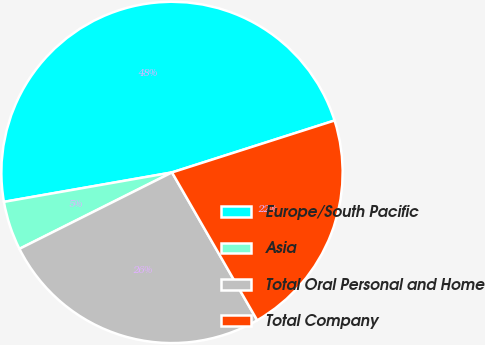Convert chart. <chart><loc_0><loc_0><loc_500><loc_500><pie_chart><fcel>Europe/South Pacific<fcel>Asia<fcel>Total Oral Personal and Home<fcel>Total Company<nl><fcel>47.84%<fcel>4.63%<fcel>25.93%<fcel>21.6%<nl></chart> 